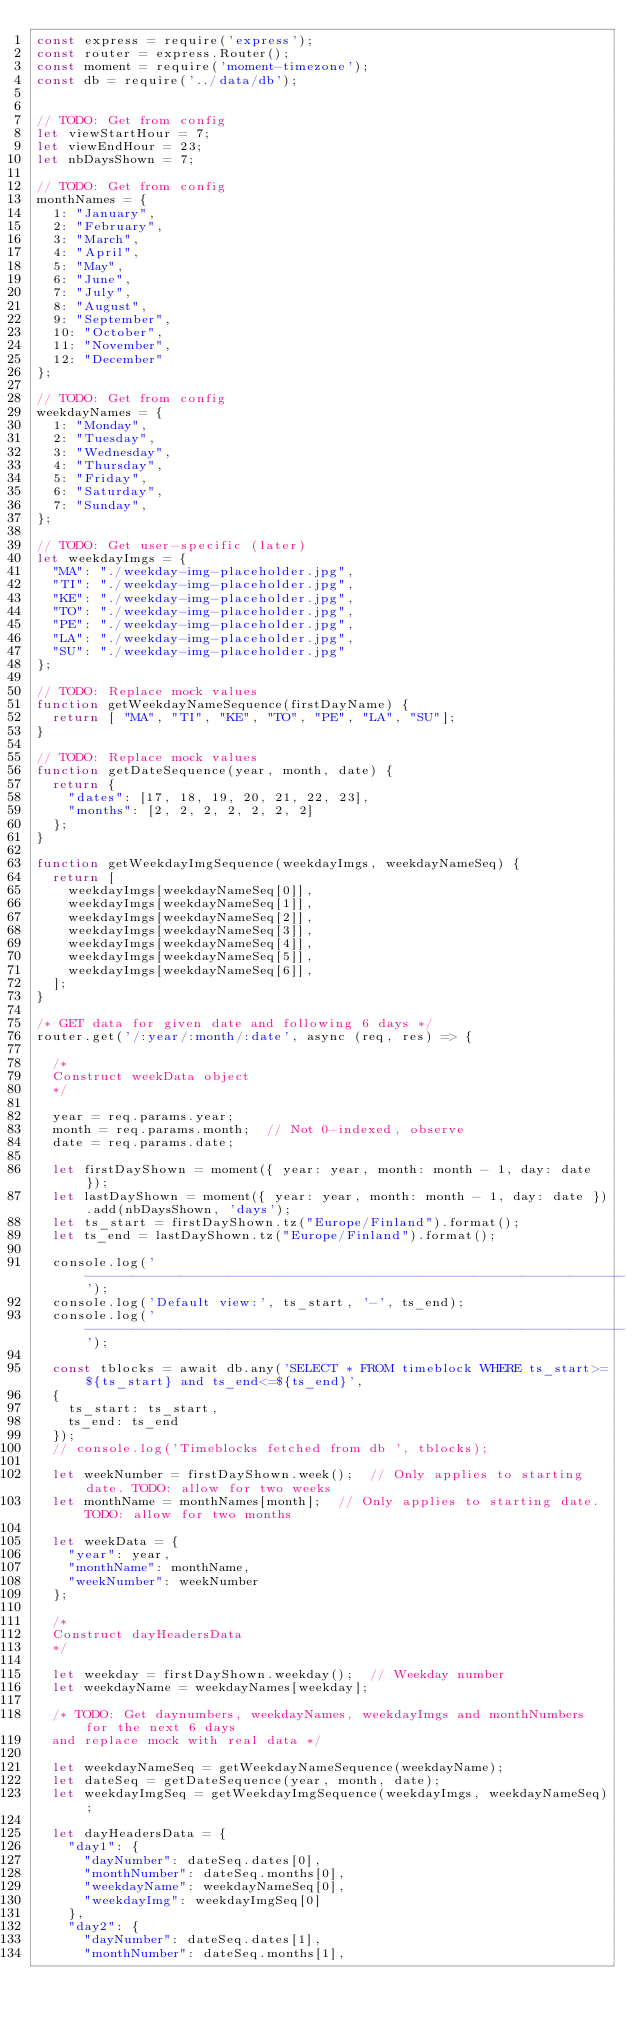<code> <loc_0><loc_0><loc_500><loc_500><_JavaScript_>const express = require('express');
const router = express.Router();
const moment = require('moment-timezone');
const db = require('../data/db');


// TODO: Get from config
let viewStartHour = 7;
let viewEndHour = 23;
let nbDaysShown = 7;

// TODO: Get from config
monthNames = {
  1: "January",
  2: "February",
  3: "March",
  4: "April",
  5: "May",
  6: "June",
  7: "July",
  8: "August",
  9: "September",
  10: "October",
  11: "November",
  12: "December"
};

// TODO: Get from config
weekdayNames = {
  1: "Monday",
  2: "Tuesday",
  3: "Wednesday",
  4: "Thursday",
  5: "Friday",
  6: "Saturday",
  7: "Sunday",
};

// TODO: Get user-specific (later)
let weekdayImgs = {
  "MA": "./weekday-img-placeholder.jpg",
  "TI": "./weekday-img-placeholder.jpg",
  "KE": "./weekday-img-placeholder.jpg",
  "TO": "./weekday-img-placeholder.jpg",
  "PE": "./weekday-img-placeholder.jpg",
  "LA": "./weekday-img-placeholder.jpg",
  "SU": "./weekday-img-placeholder.jpg"
};

// TODO: Replace mock values
function getWeekdayNameSequence(firstDayName) {
  return [ "MA", "TI", "KE", "TO", "PE", "LA", "SU"];
}

// TODO: Replace mock values
function getDateSequence(year, month, date) {
  return {
    "dates": [17, 18, 19, 20, 21, 22, 23],
    "months": [2, 2, 2, 2, 2, 2, 2]
  };
}

function getWeekdayImgSequence(weekdayImgs, weekdayNameSeq) {
  return [
    weekdayImgs[weekdayNameSeq[0]],
    weekdayImgs[weekdayNameSeq[1]],
    weekdayImgs[weekdayNameSeq[2]],
    weekdayImgs[weekdayNameSeq[3]],
    weekdayImgs[weekdayNameSeq[4]],
    weekdayImgs[weekdayNameSeq[5]],
    weekdayImgs[weekdayNameSeq[6]],
  ];
}

/* GET data for given date and following 6 days */
router.get('/:year/:month/:date', async (req, res) => {

  /* 
  Construct weekData object
  */

  year = req.params.year;
  month = req.params.month;  // Not 0-indexed, observe
  date = req.params.date;

  let firstDayShown = moment({ year: year, month: month - 1, day: date });
  let lastDayShown = moment({ year: year, month: month - 1, day: date }).add(nbDaysShown, 'days');
  let ts_start = firstDayShown.tz("Europe/Finland").format();
  let ts_end = lastDayShown.tz("Europe/Finland").format();

  console.log('--------------------------------------------------------------------');
  console.log('Default view:', ts_start, '-', ts_end);
  console.log('--------------------------------------------------------------------');

  const tblocks = await db.any('SELECT * FROM timeblock WHERE ts_start>=${ts_start} and ts_end<=${ts_end}',
  {
    ts_start: ts_start,
    ts_end: ts_end
  });
  // console.log('Timeblocks fetched from db ', tblocks);

  let weekNumber = firstDayShown.week();  // Only applies to starting date. TODO: allow for two weeks
  let monthName = monthNames[month];  // Only applies to starting date. TODO: allow for two months

  let weekData = {
    "year": year,
    "monthName": monthName,
    "weekNumber": weekNumber
  };

  /*
  Construct dayHeadersData
  */

  let weekday = firstDayShown.weekday();  // Weekday number
  let weekdayName = weekdayNames[weekday];

  /* TODO: Get daynumbers, weekdayNames, weekdayImgs and monthNumbers for the next 6 days
  and replace mock with real data */

  let weekdayNameSeq = getWeekdayNameSequence(weekdayName); 
  let dateSeq = getDateSequence(year, month, date);
  let weekdayImgSeq = getWeekdayImgSequence(weekdayImgs, weekdayNameSeq);

  let dayHeadersData = {
    "day1": {
      "dayNumber": dateSeq.dates[0],
      "monthNumber": dateSeq.months[0],
      "weekdayName": weekdayNameSeq[0],
      "weekdayImg": weekdayImgSeq[0]
    },
    "day2": {
      "dayNumber": dateSeq.dates[1],
      "monthNumber": dateSeq.months[1],</code> 